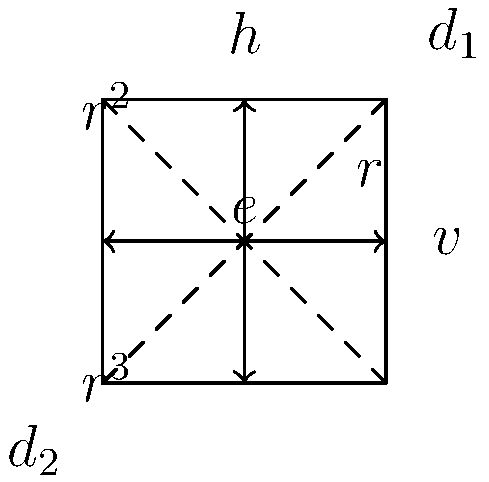In the context of simplified build tools and workflows, consider the symmetry group of a square. How many unique elements are in this group, and what is the order of the rotation element $r$? To answer this question, let's break it down step-by-step:

1. Identify the elements of the symmetry group:
   - Identity (e): No change
   - Rotations (r): 90° clockwise, 180°, 270° clockwise
   - Reflections: Horizontal (h), Vertical (v), Diagonal (d1, d2)

2. Count the unique elements:
   - 1 identity element (e)
   - 3 rotations (r, r^2, r^3)
   - 4 reflections (h, v, d1, d2)
   Total: 1 + 3 + 4 = 8 unique elements

3. Determine the order of the rotation element r:
   - r represents a 90° clockwise rotation
   - We need to apply r multiple times to get back to the identity:
     r (90°) → r^2 (180°) → r^3 (270°) → r^4 (360° = 0° = identity)
   - It takes 4 applications of r to return to the identity
   
4. Relate to simplified build tools and workflows:
   Understanding group theory and symmetries can help in designing more efficient and streamlined build processes. Just as we've simplified the square's symmetries into a concise group, we can apply similar principles to simplify complex build workflows.
Answer: 8 elements; order of r is 4 